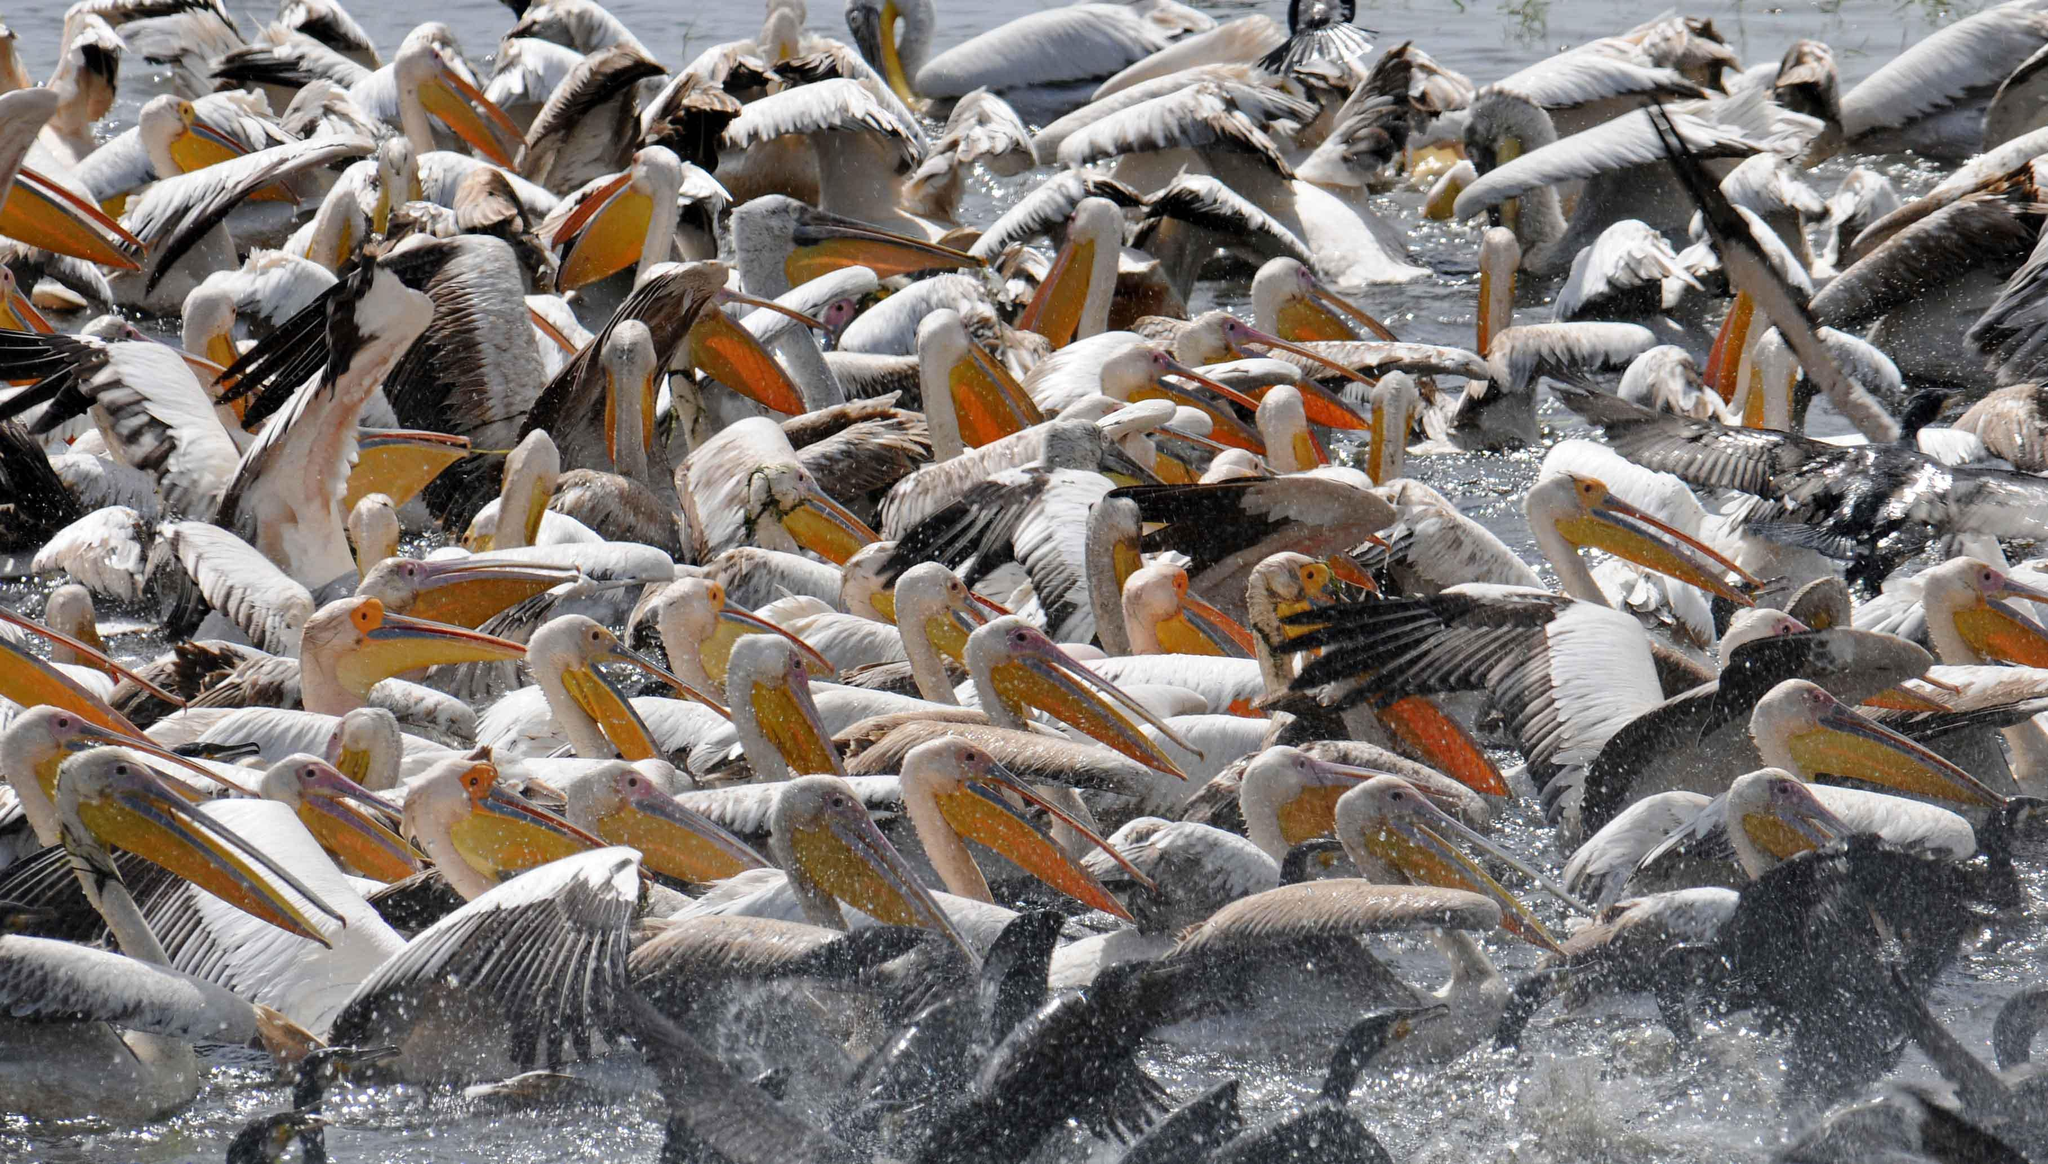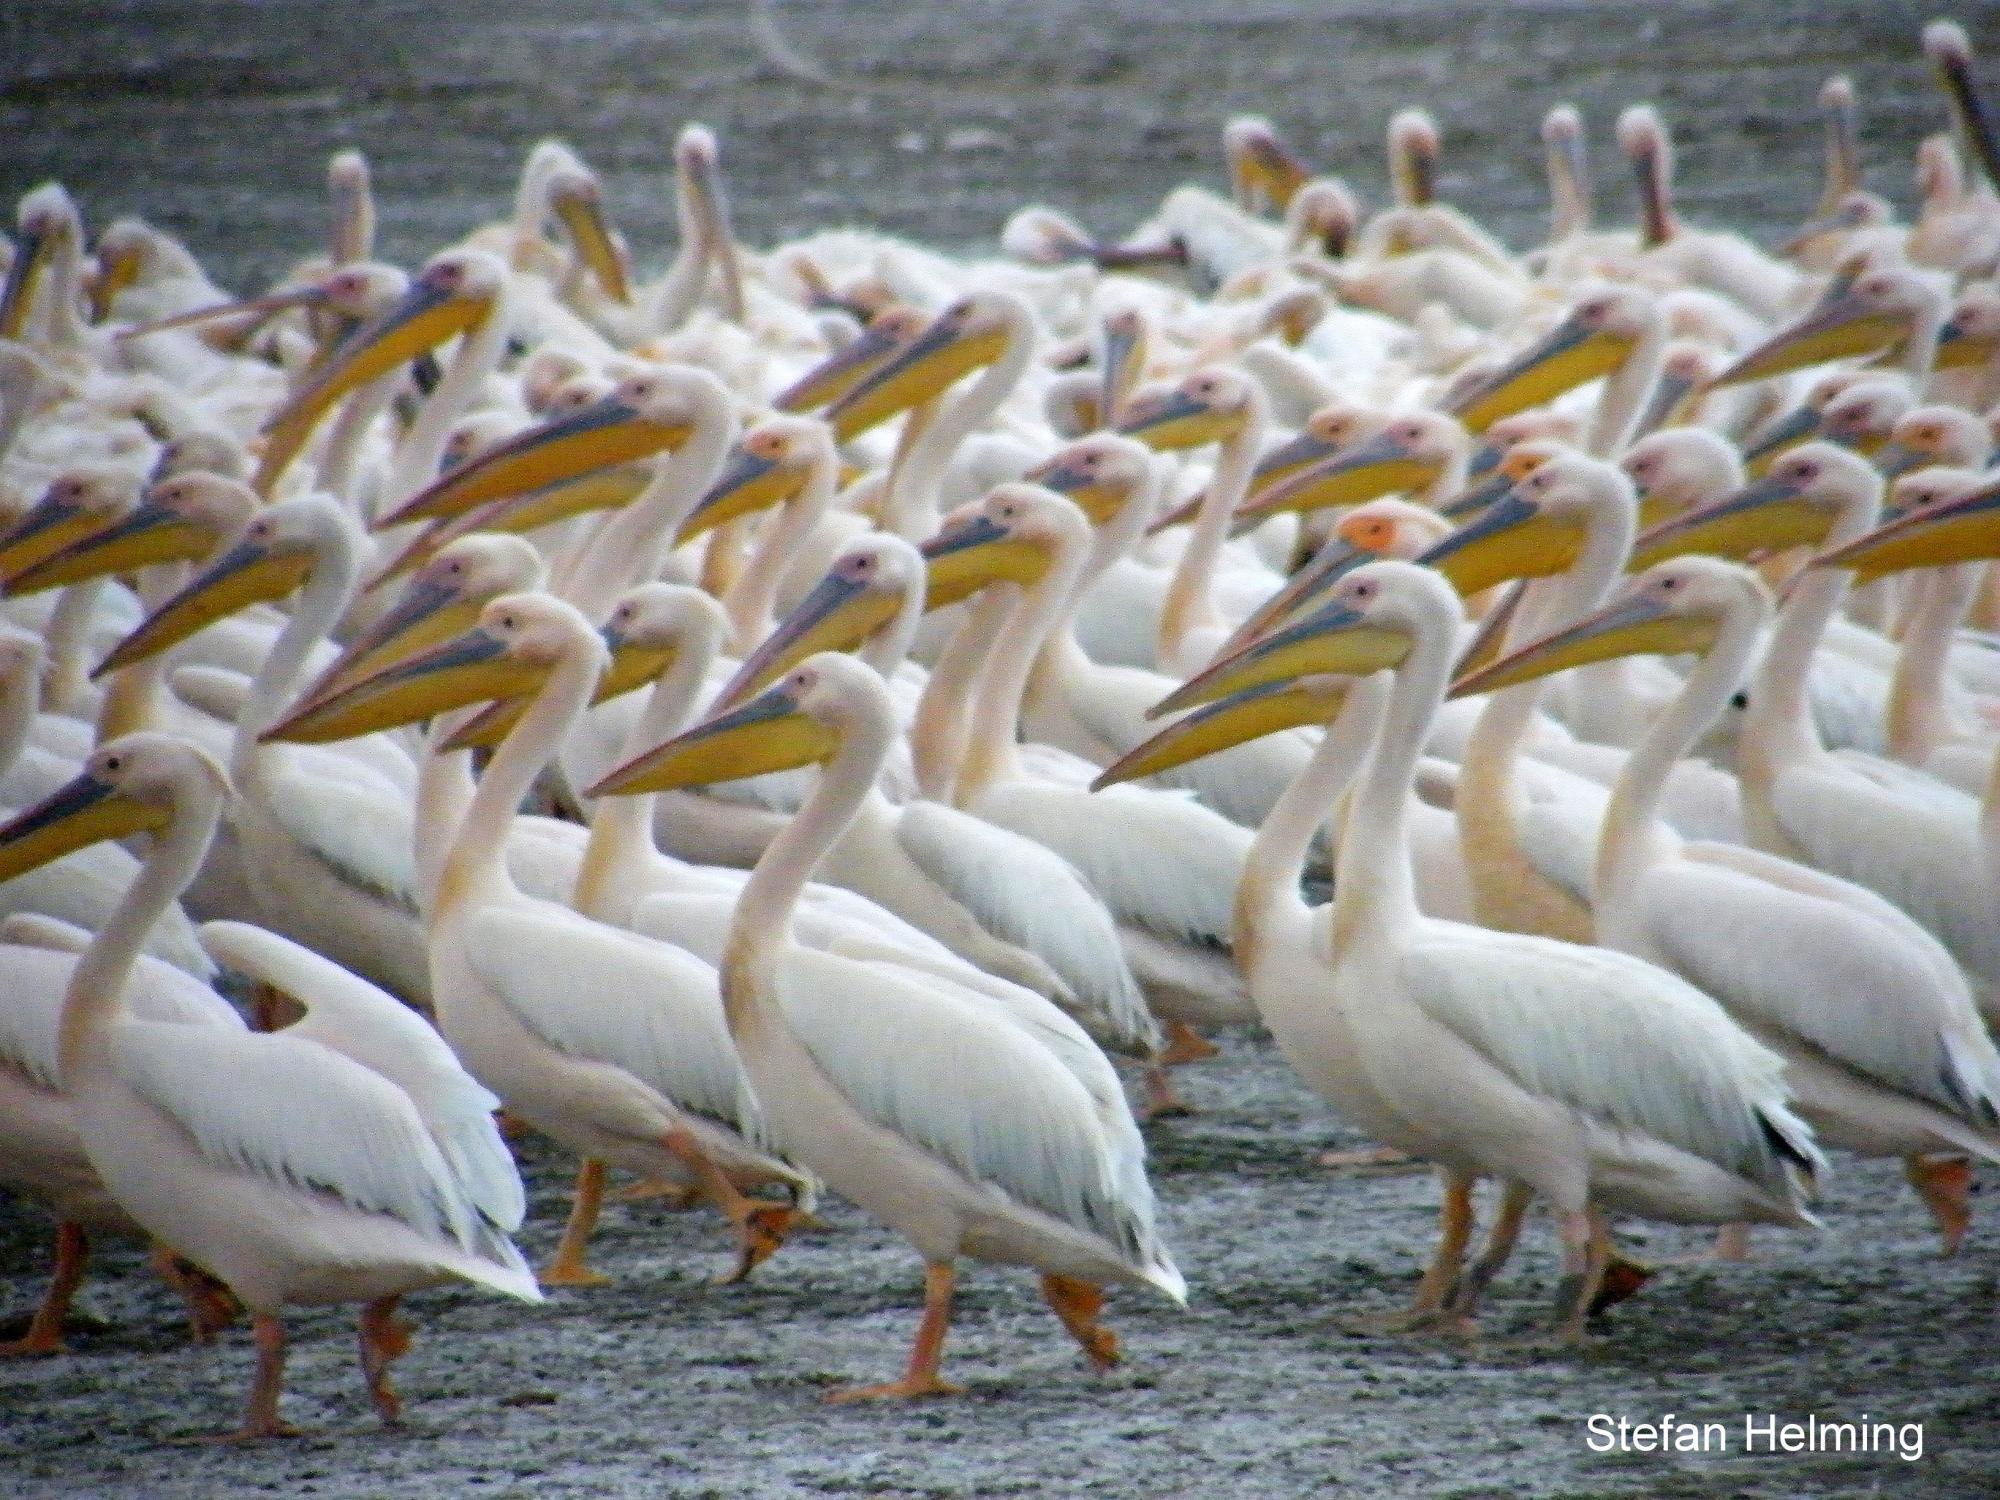The first image is the image on the left, the second image is the image on the right. For the images shown, is this caption "The left image shows one pelican floating on the water" true? Answer yes or no. No. The first image is the image on the left, the second image is the image on the right. Considering the images on both sides, is "Left image contains only one pelican, which is on water." valid? Answer yes or no. No. 